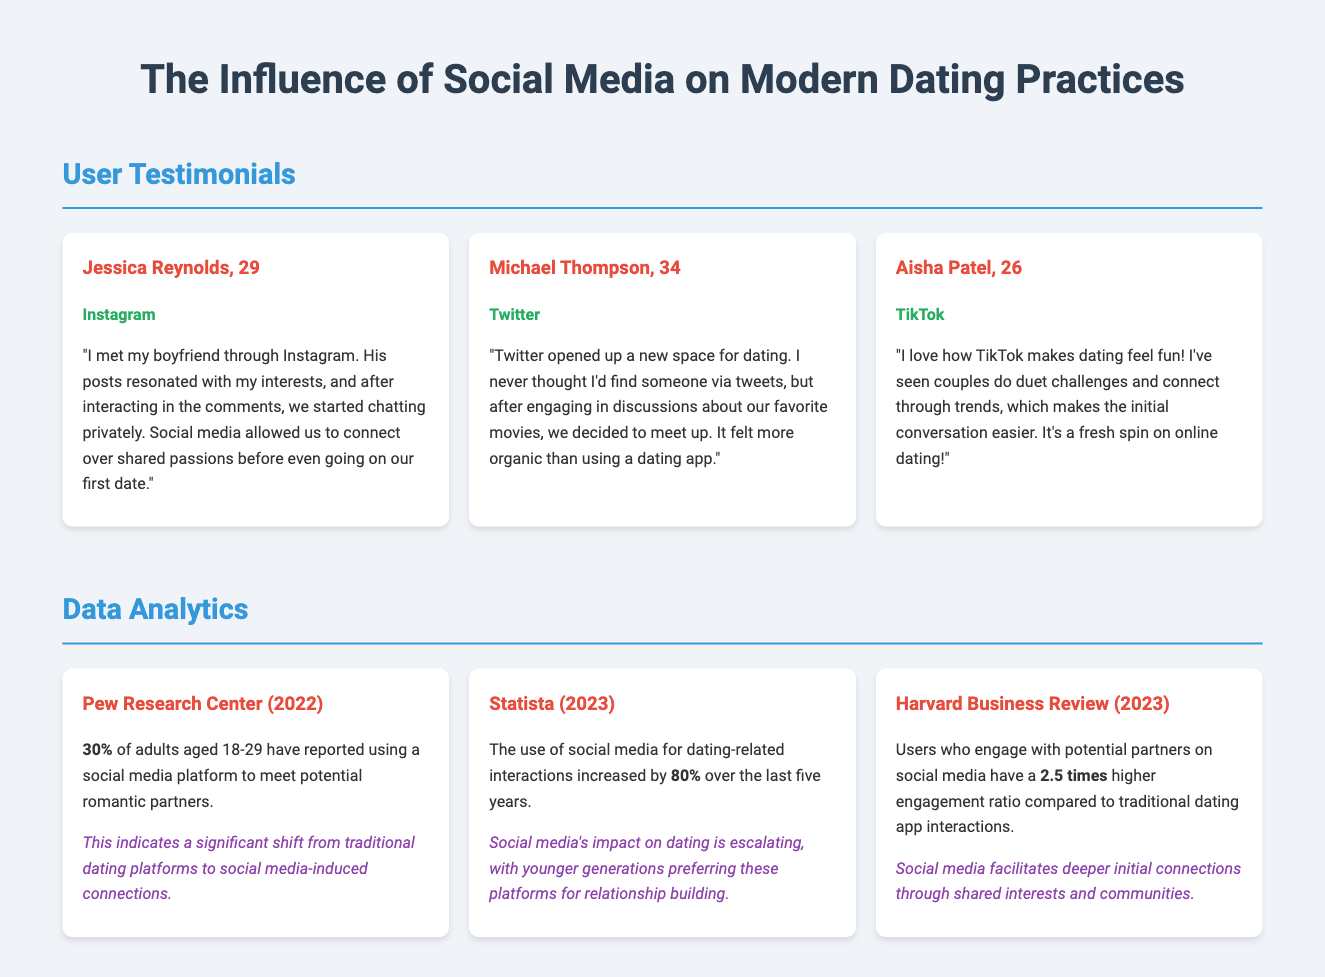What platform did Jessica use to meet her boyfriend? Jessica met her boyfriend through Instagram.
Answer: Instagram How many adults aged 18-29 reported using social media for dating? According to Pew Research Center, 30% of adults aged 18-29 used social media to meet potential romantic partners.
Answer: 30% What is the increase percentage in social media use for dating-related interactions over the last five years? Statista reports an 80% increase in social media use for dating-related interactions over the past five years.
Answer: 80% What does Aisha Patel think about TikTok's impact on dating? Aisha believes that TikTok makes dating feel fun and easier for initial conversations.
Answer: Fun What is the engagement ratio difference between social media and traditional dating app interactions? Harvard Business Review states that users engaging on social media have a 2.5 times higher engagement ratio compared to traditional dating apps.
Answer: 2.5 times What aspect of dating did Michael Thompson find more organic? Michael found meeting someone through Twitter to be more organic than using a dating app.
Answer: Organic What year did Pew Research Center publish its findings about social media and dating? Pew Research Center published its findings in 2022.
Answer: 2022 How many testimonials are featured in the document? There are three user testimonials featured in the document.
Answer: Three 